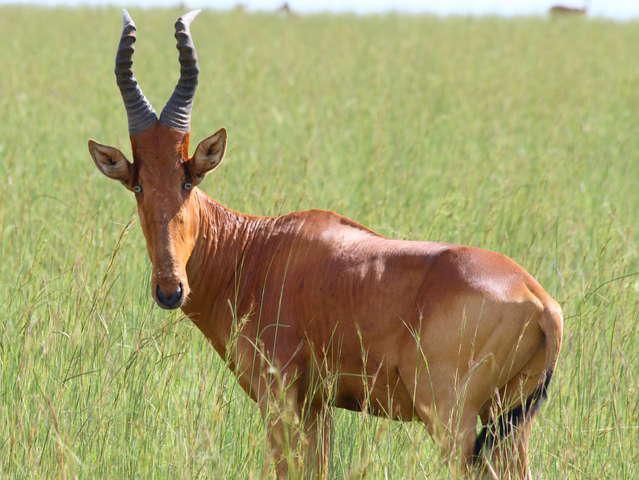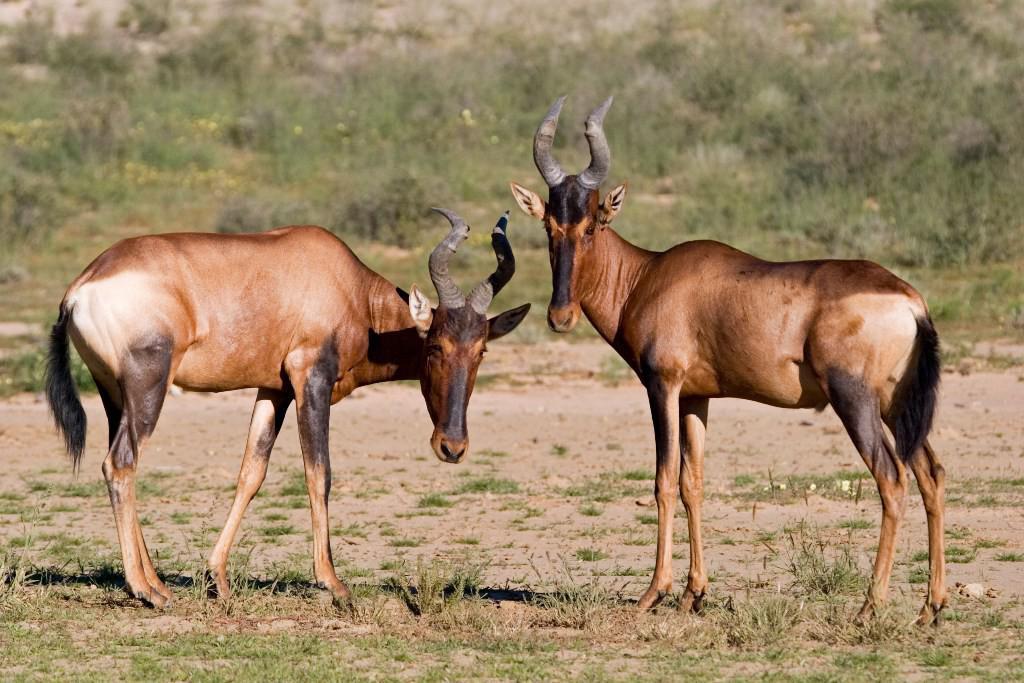The first image is the image on the left, the second image is the image on the right. Evaluate the accuracy of this statement regarding the images: "The right image shows more than one antelope-type animal.". Is it true? Answer yes or no. Yes. The first image is the image on the left, the second image is the image on the right. Considering the images on both sides, is "There are more animals in the image on the right than on the left." valid? Answer yes or no. Yes. 